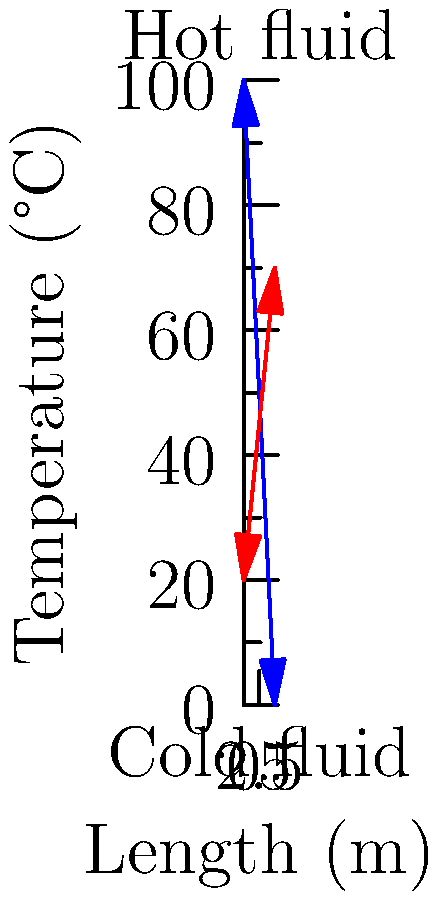In a counter-flow heat exchanger, the hot fluid enters at 100°C and exits at 0°C, while the cold fluid enters at 20°C and exits at 70°C. The length of the heat exchanger is 5 meters. What is the average temperature gradient (°C/m) for the hot fluid along the length of the heat exchanger? To find the average temperature gradient for the hot fluid, we need to follow these steps:

1. Identify the temperature change of the hot fluid:
   Initial temperature = 100°C
   Final temperature = 0°C
   Temperature change = 100°C - 0°C = 100°C

2. Determine the length of the heat exchanger:
   Length = 5 meters

3. Calculate the average temperature gradient using the formula:
   $$ \text{Average Temperature Gradient} = \frac{\text{Temperature Change}}{\text{Length}} $$

4. Substitute the values:
   $$ \text{Average Temperature Gradient} = \frac{100°C}{5\text{ m}} = 20°C/m $$

5. The negative sign indicates that the temperature is decreasing along the length of the heat exchanger for the hot fluid.

Therefore, the average temperature gradient for the hot fluid is -20°C/m.
Answer: -20°C/m 